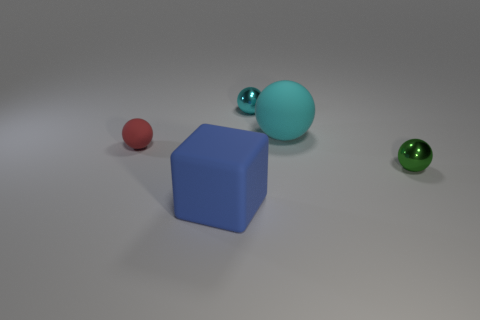What is the material of the cyan object that is in front of the small metallic object on the left side of the tiny green thing?
Provide a short and direct response. Rubber. What is the shape of the blue object that is made of the same material as the large cyan object?
Provide a succinct answer. Cube. Is there anything else that is the same shape as the red thing?
Your answer should be compact. Yes. How many small spheres are right of the big block?
Provide a succinct answer. 2. Are there any green shiny balls?
Give a very brief answer. Yes. There is a rubber sphere on the left side of the small metallic thing behind the small thing to the left of the large rubber block; what is its color?
Provide a succinct answer. Red. There is a big thing behind the small red matte thing; is there a large cyan ball that is on the right side of it?
Make the answer very short. No. Do the small ball that is behind the tiny red ball and the sphere that is on the left side of the cyan metal object have the same color?
Provide a short and direct response. No. How many red objects have the same size as the green ball?
Keep it short and to the point. 1. There is a matte object to the right of the cyan metallic object; is it the same size as the large cube?
Offer a terse response. Yes. 